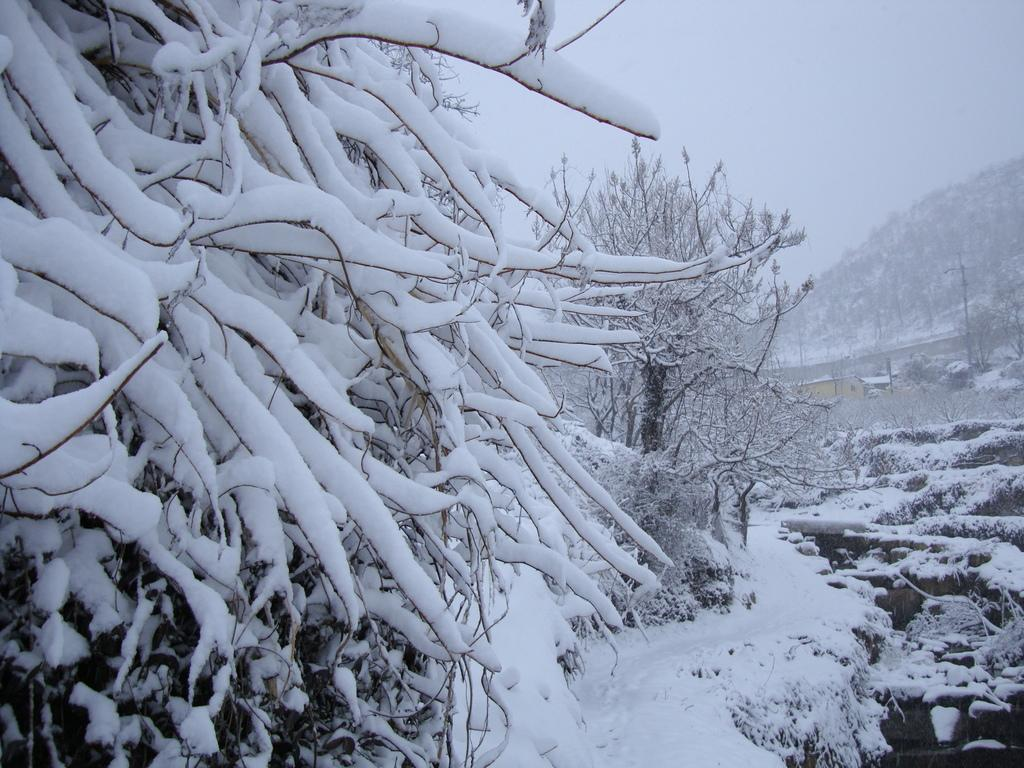What type of vegetation can be seen in the image? There are trees in the image. What is covering the trees in the image? The trees are covered with snow. What is visible at the top of the image? The sky is visible at the top of the image. Can you tell me how many people are playing chess in the image? There is no chess game or group of people present in the image; it features trees covered in snow. 